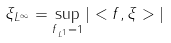Convert formula to latex. <formula><loc_0><loc_0><loc_500><loc_500>\| \xi \| _ { L ^ { \infty } } = \sup _ { \| f \| _ { L ^ { 1 } } = 1 } | < f , \xi > |</formula> 